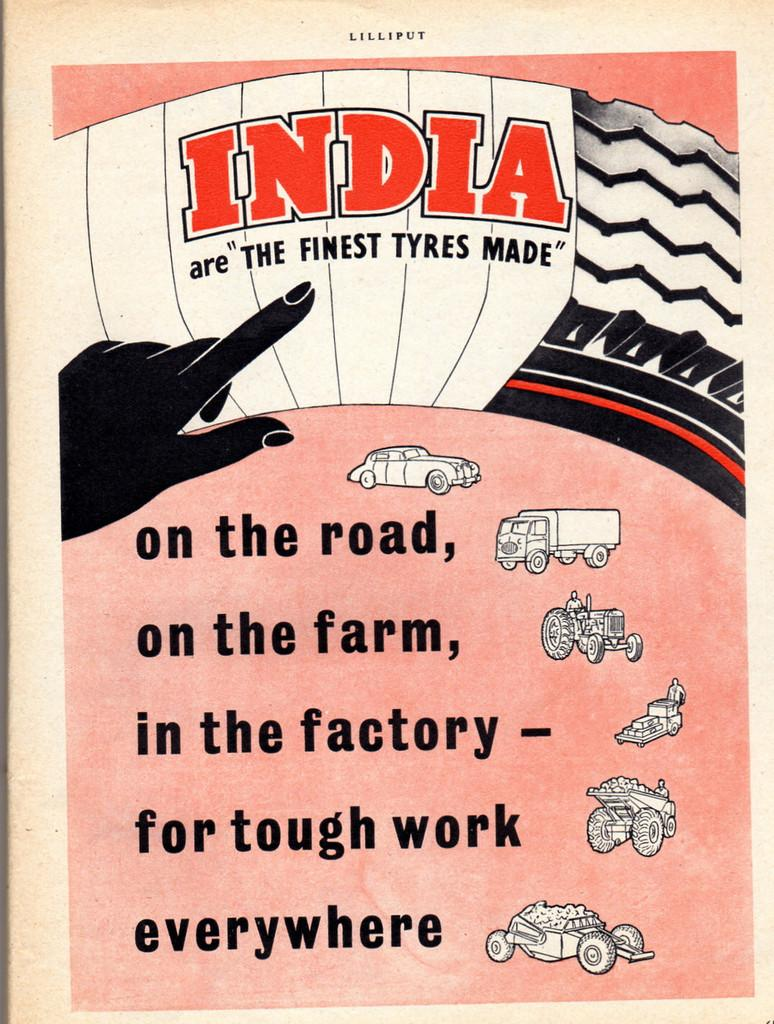What is present on the left side of the image? There is a poster in the image. What can be seen on the right side of the poster? There are images of vehicles on the right side of the poster. What else is featured on the poster besides the images of vehicles? Some matter is written on the poster. How many balls are bouncing around the poster in the image? There are no balls present in the image; the poster features images of vehicles and written matter. 